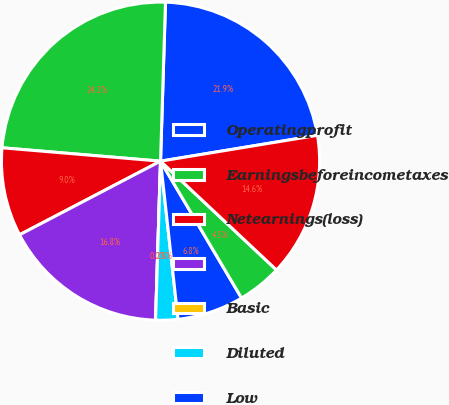Convert chart to OTSL. <chart><loc_0><loc_0><loc_500><loc_500><pie_chart><fcel>Operatingprofit<fcel>Earningsbeforeincometaxes<fcel>Netearnings(loss)<fcel>Unnamed: 3<fcel>Basic<fcel>Diluted<fcel>Low<fcel>Cashdividendsdeclared<fcel>Netearnings<nl><fcel>21.9%<fcel>24.15%<fcel>9.0%<fcel>16.84%<fcel>0.0%<fcel>2.25%<fcel>6.75%<fcel>4.5%<fcel>14.59%<nl></chart> 